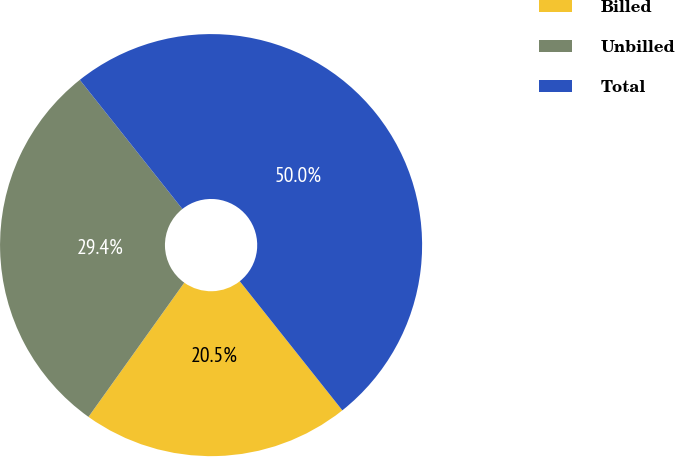Convert chart. <chart><loc_0><loc_0><loc_500><loc_500><pie_chart><fcel>Billed<fcel>Unbilled<fcel>Total<nl><fcel>20.55%<fcel>29.45%<fcel>50.0%<nl></chart> 